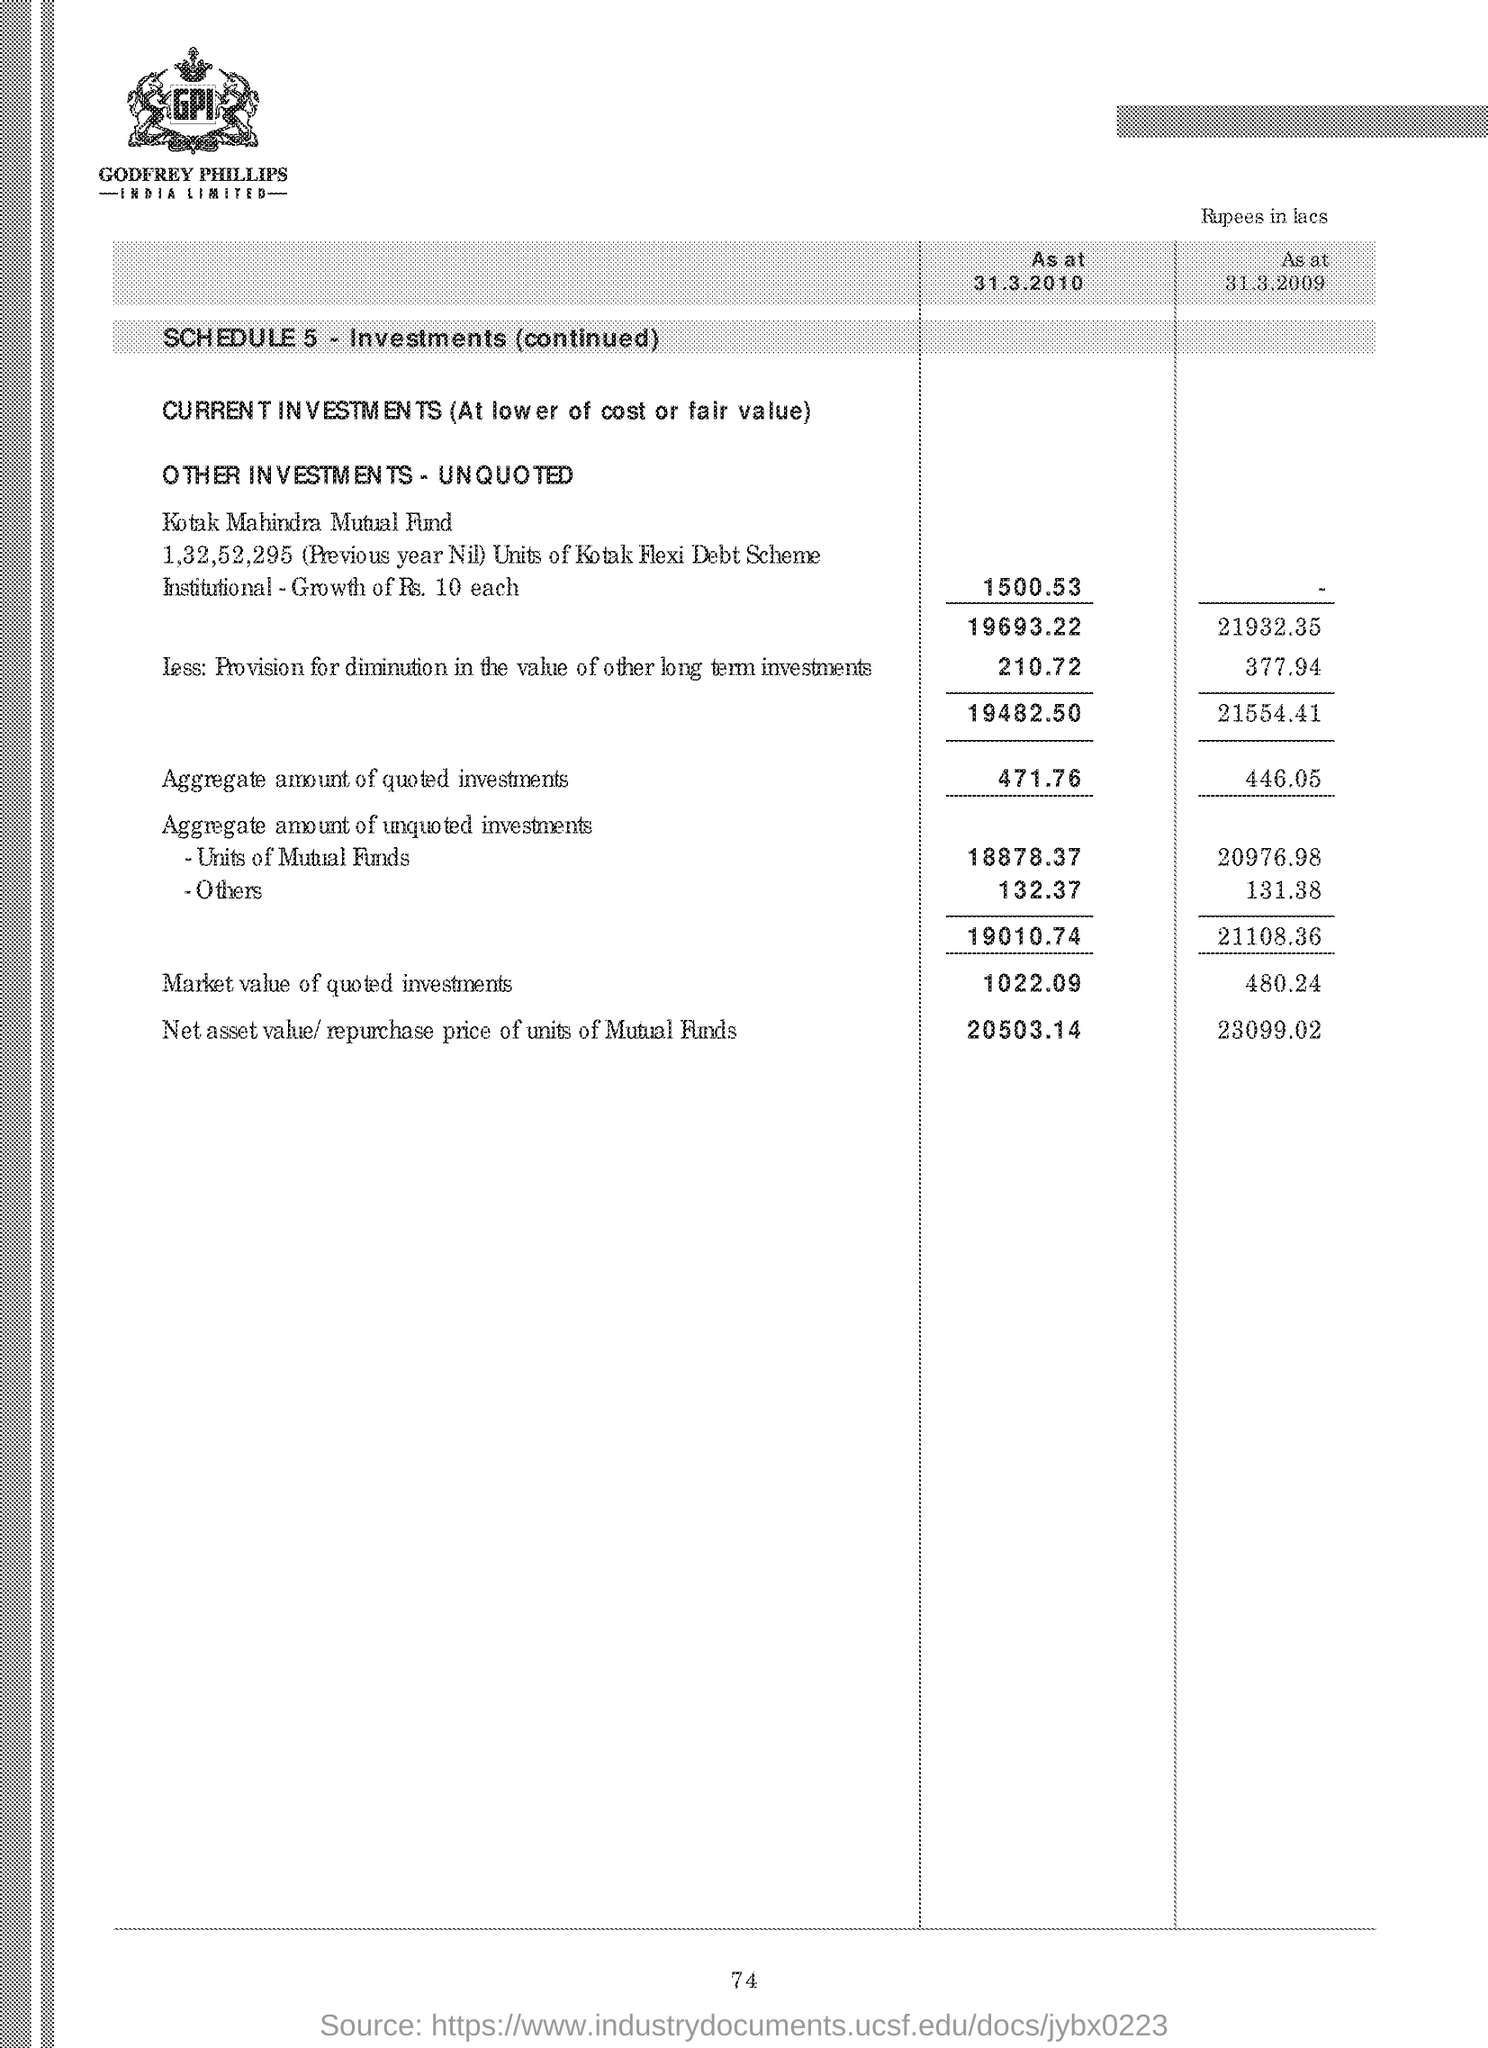What are the LETTERS written in the company logo at the top ?
Ensure brevity in your answer.  GPI. What is the SCHEDULE number of Investments?
Provide a succinct answer. 5. What is the aggregate amount of quoted investments at 31.3.2010 ?
Offer a very short reply. 471.76. How much is the Net asset value/repurchase price of units of Mutual Funds at 31.3.2010 ?
Provide a short and direct response. 20503.14. 